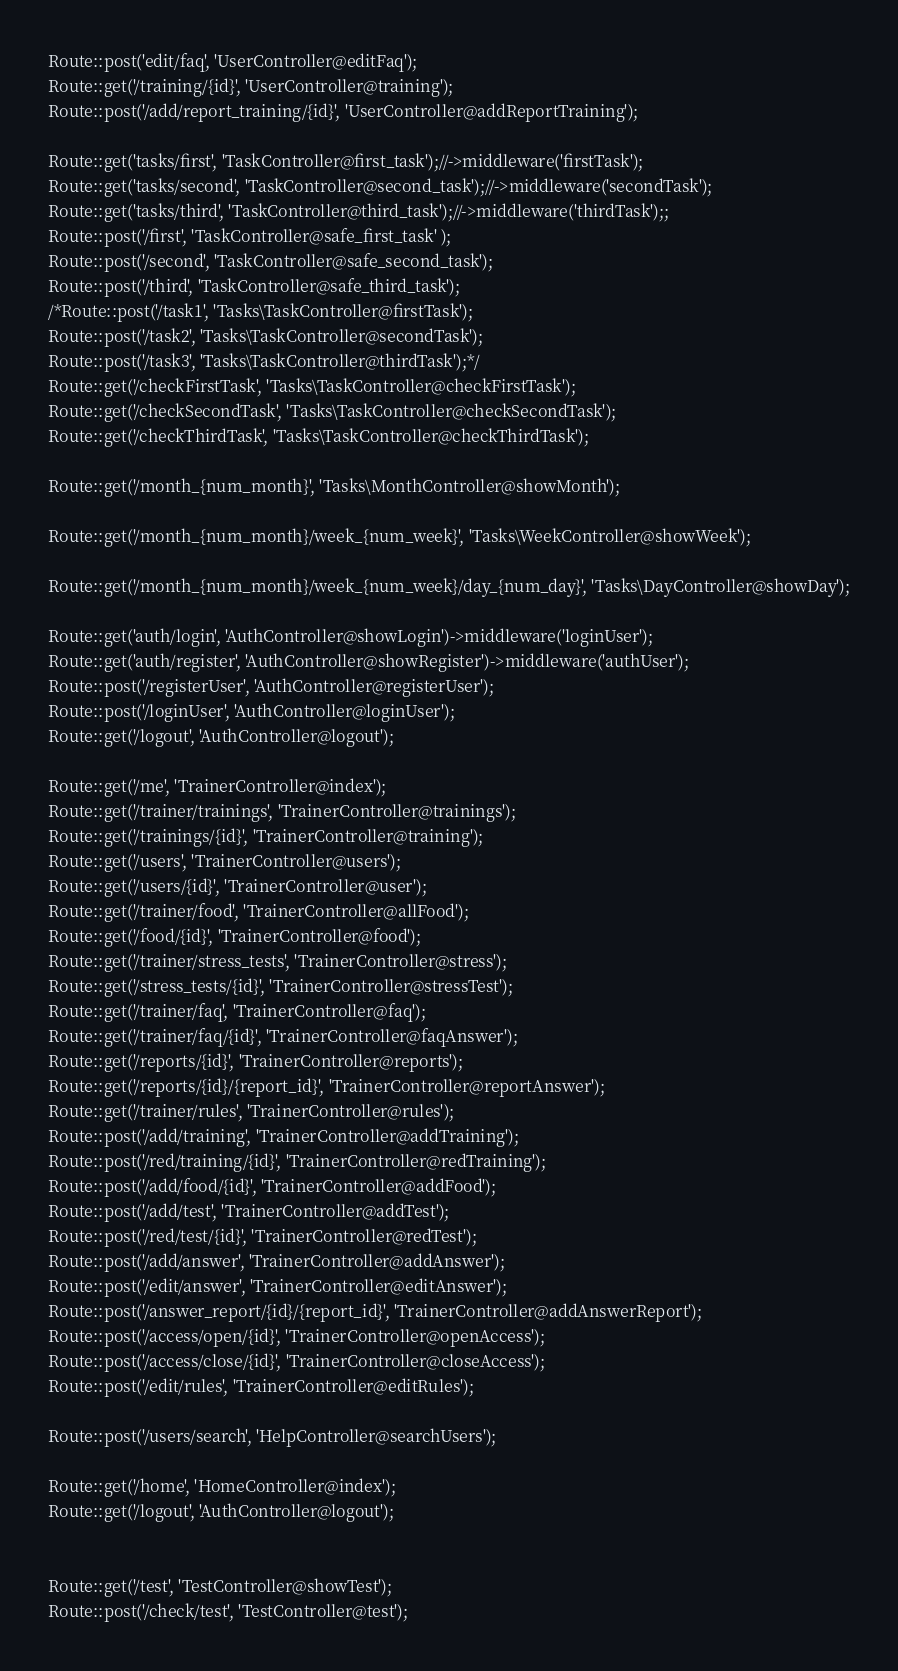<code> <loc_0><loc_0><loc_500><loc_500><_PHP_>Route::post('edit/faq', 'UserController@editFaq');
Route::get('/training/{id}', 'UserController@training');
Route::post('/add/report_training/{id}', 'UserController@addReportTraining');

Route::get('tasks/first', 'TaskController@first_task');//->middleware('firstTask');
Route::get('tasks/second', 'TaskController@second_task');//->middleware('secondTask');
Route::get('tasks/third', 'TaskController@third_task');//->middleware('thirdTask');;
Route::post('/first', 'TaskController@safe_first_task' );
Route::post('/second', 'TaskController@safe_second_task');
Route::post('/third', 'TaskController@safe_third_task');
/*Route::post('/task1', 'Tasks\TaskController@firstTask');
Route::post('/task2', 'Tasks\TaskController@secondTask');
Route::post('/task3', 'Tasks\TaskController@thirdTask');*/
Route::get('/checkFirstTask', 'Tasks\TaskController@checkFirstTask');
Route::get('/checkSecondTask', 'Tasks\TaskController@checkSecondTask');
Route::get('/checkThirdTask', 'Tasks\TaskController@checkThirdTask');

Route::get('/month_{num_month}', 'Tasks\MonthController@showMonth');

Route::get('/month_{num_month}/week_{num_week}', 'Tasks\WeekController@showWeek');

Route::get('/month_{num_month}/week_{num_week}/day_{num_day}', 'Tasks\DayController@showDay');

Route::get('auth/login', 'AuthController@showLogin')->middleware('loginUser');
Route::get('auth/register', 'AuthController@showRegister')->middleware('authUser');
Route::post('/registerUser', 'AuthController@registerUser');
Route::post('/loginUser', 'AuthController@loginUser');
Route::get('/logout', 'AuthController@logout');

Route::get('/me', 'TrainerController@index');
Route::get('/trainer/trainings', 'TrainerController@trainings');
Route::get('/trainings/{id}', 'TrainerController@training');
Route::get('/users', 'TrainerController@users');
Route::get('/users/{id}', 'TrainerController@user');
Route::get('/trainer/food', 'TrainerController@allFood');
Route::get('/food/{id}', 'TrainerController@food');
Route::get('/trainer/stress_tests', 'TrainerController@stress');
Route::get('/stress_tests/{id}', 'TrainerController@stressTest');
Route::get('/trainer/faq', 'TrainerController@faq');
Route::get('/trainer/faq/{id}', 'TrainerController@faqAnswer');
Route::get('/reports/{id}', 'TrainerController@reports');
Route::get('/reports/{id}/{report_id}', 'TrainerController@reportAnswer');
Route::get('/trainer/rules', 'TrainerController@rules');
Route::post('/add/training', 'TrainerController@addTraining');
Route::post('/red/training/{id}', 'TrainerController@redTraining');
Route::post('/add/food/{id}', 'TrainerController@addFood');
Route::post('/add/test', 'TrainerController@addTest');
Route::post('/red/test/{id}', 'TrainerController@redTest');
Route::post('/add/answer', 'TrainerController@addAnswer');
Route::post('/edit/answer', 'TrainerController@editAnswer');
Route::post('/answer_report/{id}/{report_id}', 'TrainerController@addAnswerReport');
Route::post('/access/open/{id}', 'TrainerController@openAccess');
Route::post('/access/close/{id}', 'TrainerController@closeAccess');
Route::post('/edit/rules', 'TrainerController@editRules');

Route::post('/users/search', 'HelpController@searchUsers');

Route::get('/home', 'HomeController@index');
Route::get('/logout', 'AuthController@logout');


Route::get('/test', 'TestController@showTest');
Route::post('/check/test', 'TestController@test');
</code> 